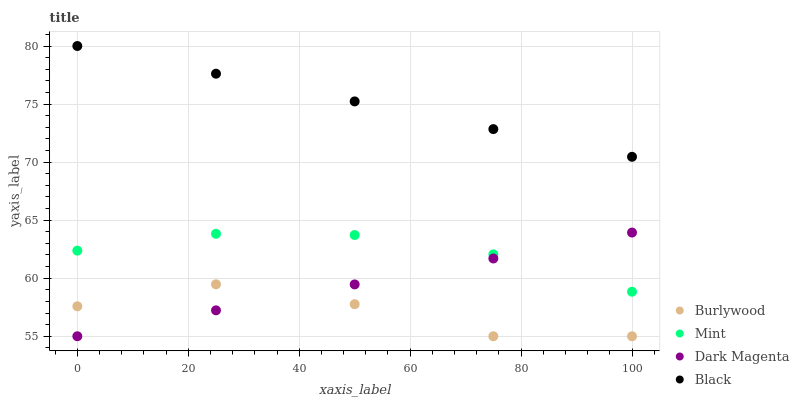Does Burlywood have the minimum area under the curve?
Answer yes or no. Yes. Does Black have the maximum area under the curve?
Answer yes or no. Yes. Does Mint have the minimum area under the curve?
Answer yes or no. No. Does Mint have the maximum area under the curve?
Answer yes or no. No. Is Black the smoothest?
Answer yes or no. Yes. Is Burlywood the roughest?
Answer yes or no. Yes. Is Mint the smoothest?
Answer yes or no. No. Is Mint the roughest?
Answer yes or no. No. Does Burlywood have the lowest value?
Answer yes or no. Yes. Does Mint have the lowest value?
Answer yes or no. No. Does Black have the highest value?
Answer yes or no. Yes. Does Mint have the highest value?
Answer yes or no. No. Is Burlywood less than Black?
Answer yes or no. Yes. Is Mint greater than Burlywood?
Answer yes or no. Yes. Does Mint intersect Dark Magenta?
Answer yes or no. Yes. Is Mint less than Dark Magenta?
Answer yes or no. No. Is Mint greater than Dark Magenta?
Answer yes or no. No. Does Burlywood intersect Black?
Answer yes or no. No. 